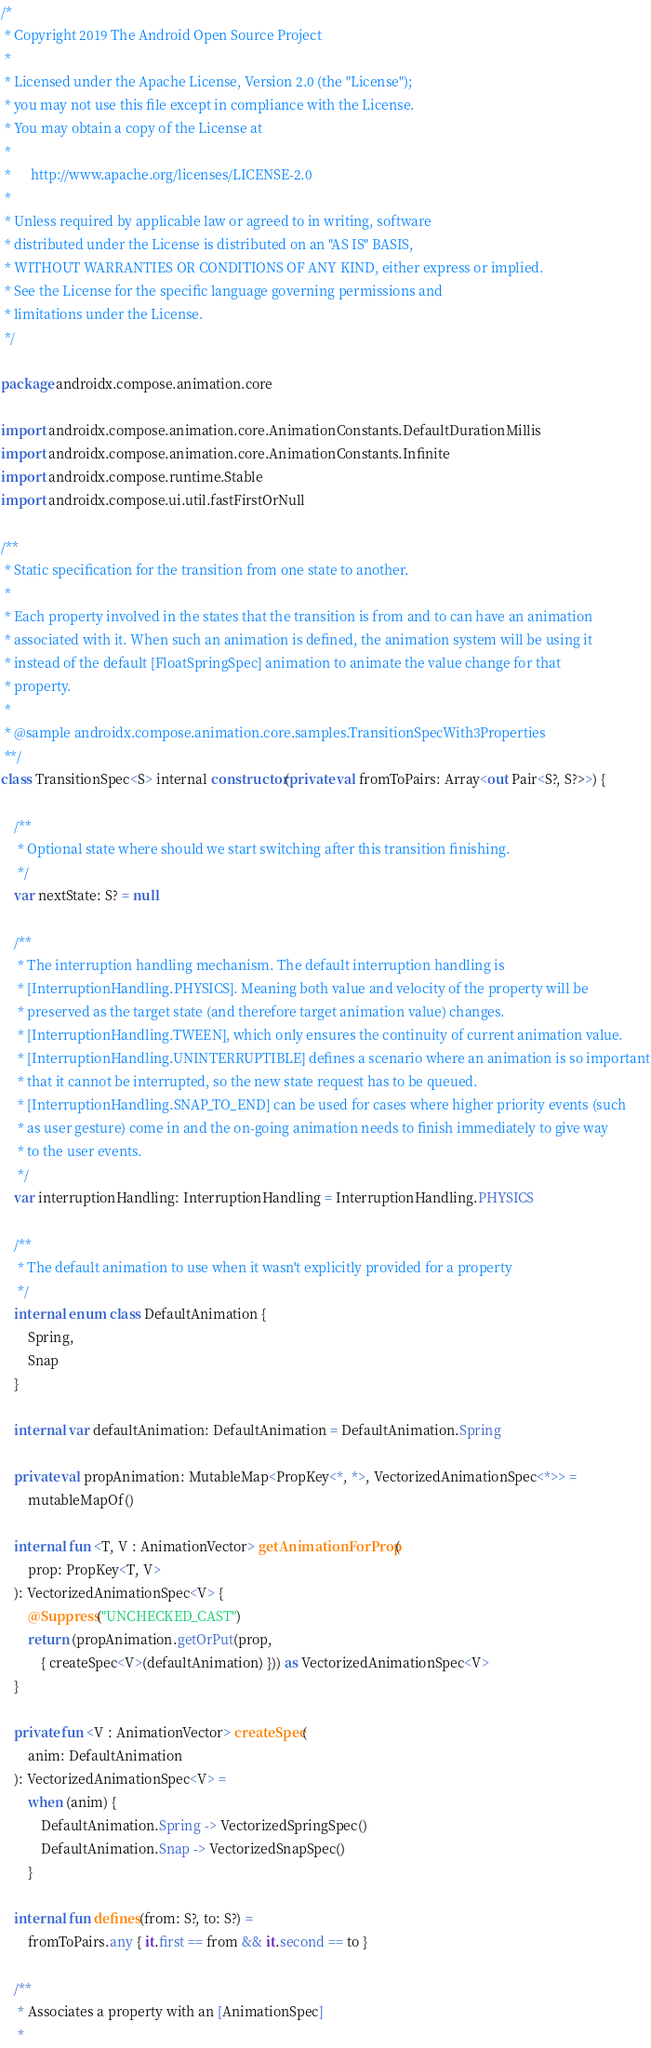<code> <loc_0><loc_0><loc_500><loc_500><_Kotlin_>/*
 * Copyright 2019 The Android Open Source Project
 *
 * Licensed under the Apache License, Version 2.0 (the "License");
 * you may not use this file except in compliance with the License.
 * You may obtain a copy of the License at
 *
 *      http://www.apache.org/licenses/LICENSE-2.0
 *
 * Unless required by applicable law or agreed to in writing, software
 * distributed under the License is distributed on an "AS IS" BASIS,
 * WITHOUT WARRANTIES OR CONDITIONS OF ANY KIND, either express or implied.
 * See the License for the specific language governing permissions and
 * limitations under the License.
 */

package androidx.compose.animation.core

import androidx.compose.animation.core.AnimationConstants.DefaultDurationMillis
import androidx.compose.animation.core.AnimationConstants.Infinite
import androidx.compose.runtime.Stable
import androidx.compose.ui.util.fastFirstOrNull

/**
 * Static specification for the transition from one state to another.
 *
 * Each property involved in the states that the transition is from and to can have an animation
 * associated with it. When such an animation is defined, the animation system will be using it
 * instead of the default [FloatSpringSpec] animation to animate the value change for that
 * property.
 *
 * @sample androidx.compose.animation.core.samples.TransitionSpecWith3Properties
 **/
class TransitionSpec<S> internal constructor(private val fromToPairs: Array<out Pair<S?, S?>>) {

    /**
     * Optional state where should we start switching after this transition finishing.
     */
    var nextState: S? = null

    /**
     * The interruption handling mechanism. The default interruption handling is
     * [InterruptionHandling.PHYSICS]. Meaning both value and velocity of the property will be
     * preserved as the target state (and therefore target animation value) changes.
     * [InterruptionHandling.TWEEN], which only ensures the continuity of current animation value.
     * [InterruptionHandling.UNINTERRUPTIBLE] defines a scenario where an animation is so important
     * that it cannot be interrupted, so the new state request has to be queued.
     * [InterruptionHandling.SNAP_TO_END] can be used for cases where higher priority events (such
     * as user gesture) come in and the on-going animation needs to finish immediately to give way
     * to the user events.
     */
    var interruptionHandling: InterruptionHandling = InterruptionHandling.PHYSICS

    /**
     * The default animation to use when it wasn't explicitly provided for a property
     */
    internal enum class DefaultAnimation {
        Spring,
        Snap
    }

    internal var defaultAnimation: DefaultAnimation = DefaultAnimation.Spring

    private val propAnimation: MutableMap<PropKey<*, *>, VectorizedAnimationSpec<*>> =
        mutableMapOf()

    internal fun <T, V : AnimationVector> getAnimationForProp(
        prop: PropKey<T, V>
    ): VectorizedAnimationSpec<V> {
        @Suppress("UNCHECKED_CAST")
        return (propAnimation.getOrPut(prop,
            { createSpec<V>(defaultAnimation) })) as VectorizedAnimationSpec<V>
    }

    private fun <V : AnimationVector> createSpec(
        anim: DefaultAnimation
    ): VectorizedAnimationSpec<V> =
        when (anim) {
            DefaultAnimation.Spring -> VectorizedSpringSpec()
            DefaultAnimation.Snap -> VectorizedSnapSpec()
        }

    internal fun defines(from: S?, to: S?) =
        fromToPairs.any { it.first == from && it.second == to }

    /**
     * Associates a property with an [AnimationSpec]
     *</code> 